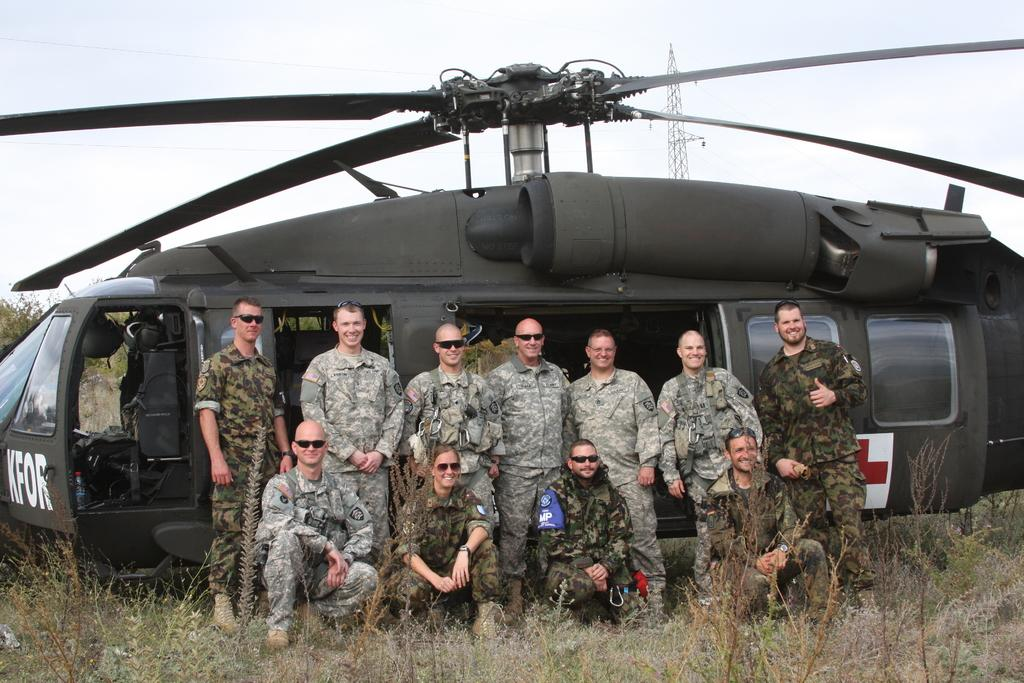What type of living organisms can be seen in the image? Plants are visible in the image. What is the main subject in the image? There is a plane in the image. What are the people in the image wearing? The people are wearing army dresses in the image. Where are the people located in the image? The people are standing in the front of the image. What is visible at the top of the image? The sky is visible at the top of the image. What type of soap is being used to clean the plane in the image? There is no soap or cleaning activity depicted in the image; it features a plane and people wearing army dresses. Can you tell me how many layers of cake are visible in the image? There is no cake present in the image. 